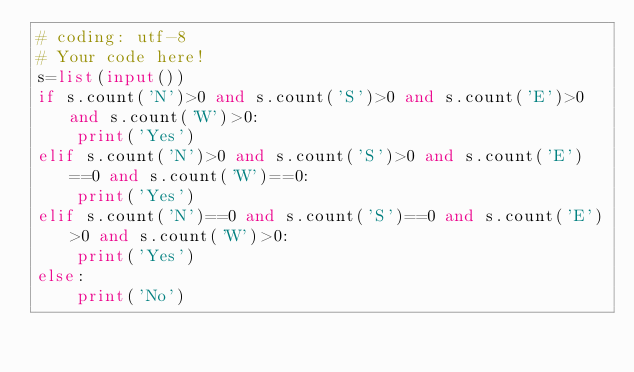Convert code to text. <code><loc_0><loc_0><loc_500><loc_500><_Python_># coding: utf-8
# Your code here!
s=list(input())
if s.count('N')>0 and s.count('S')>0 and s.count('E')>0 and s.count('W')>0:
    print('Yes')
elif s.count('N')>0 and s.count('S')>0 and s.count('E')==0 and s.count('W')==0:
    print('Yes')
elif s.count('N')==0 and s.count('S')==0 and s.count('E')>0 and s.count('W')>0:
    print('Yes')
else:
    print('No')
</code> 